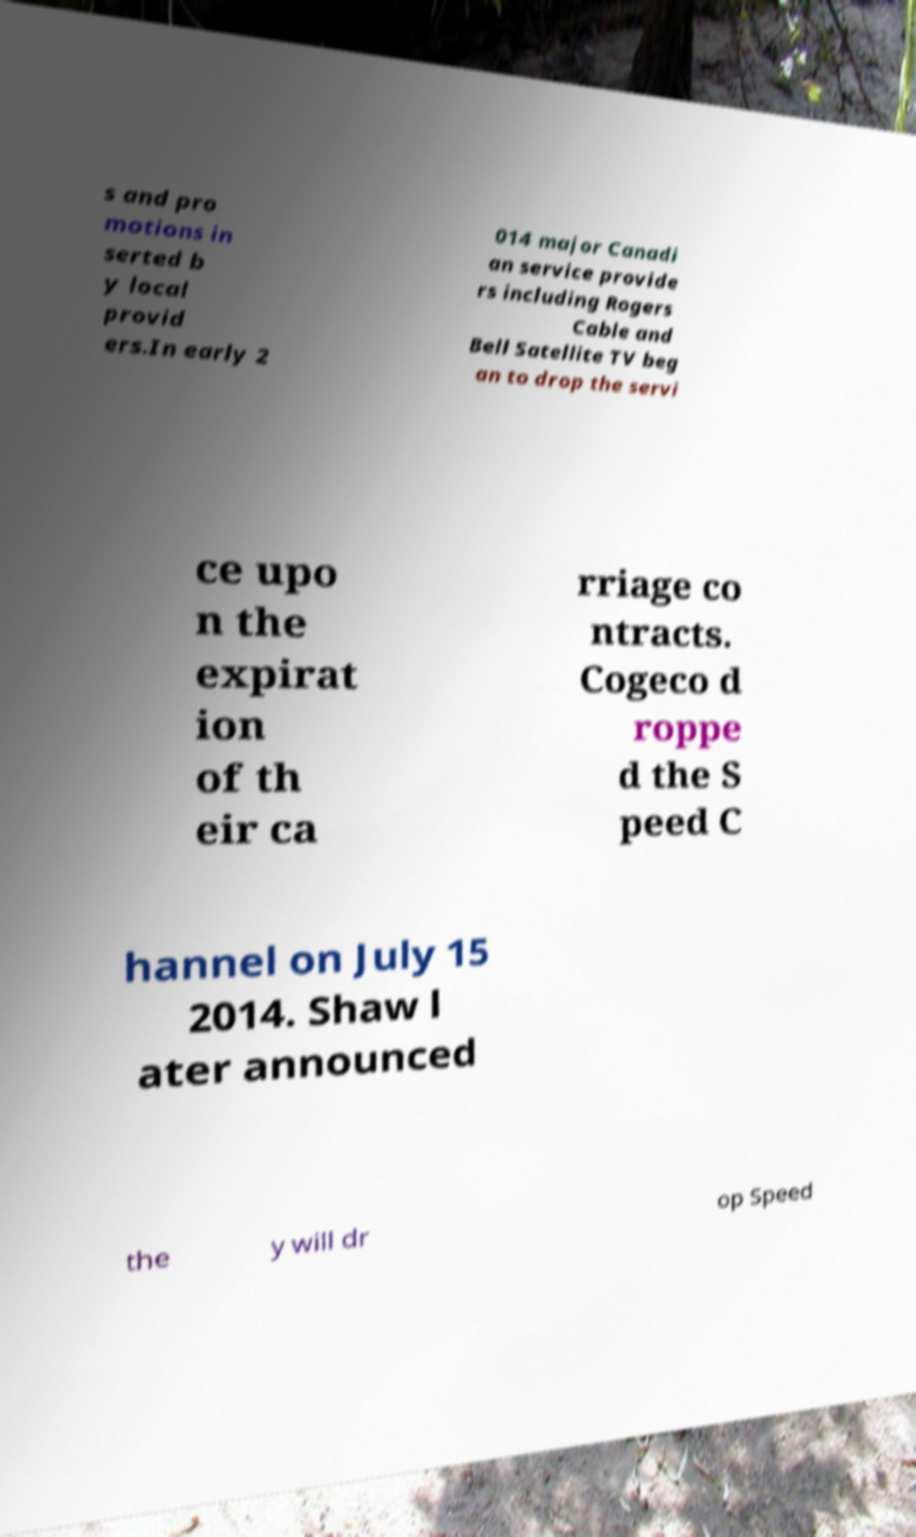Could you assist in decoding the text presented in this image and type it out clearly? s and pro motions in serted b y local provid ers.In early 2 014 major Canadi an service provide rs including Rogers Cable and Bell Satellite TV beg an to drop the servi ce upo n the expirat ion of th eir ca rriage co ntracts. Cogeco d roppe d the S peed C hannel on July 15 2014. Shaw l ater announced the y will dr op Speed 